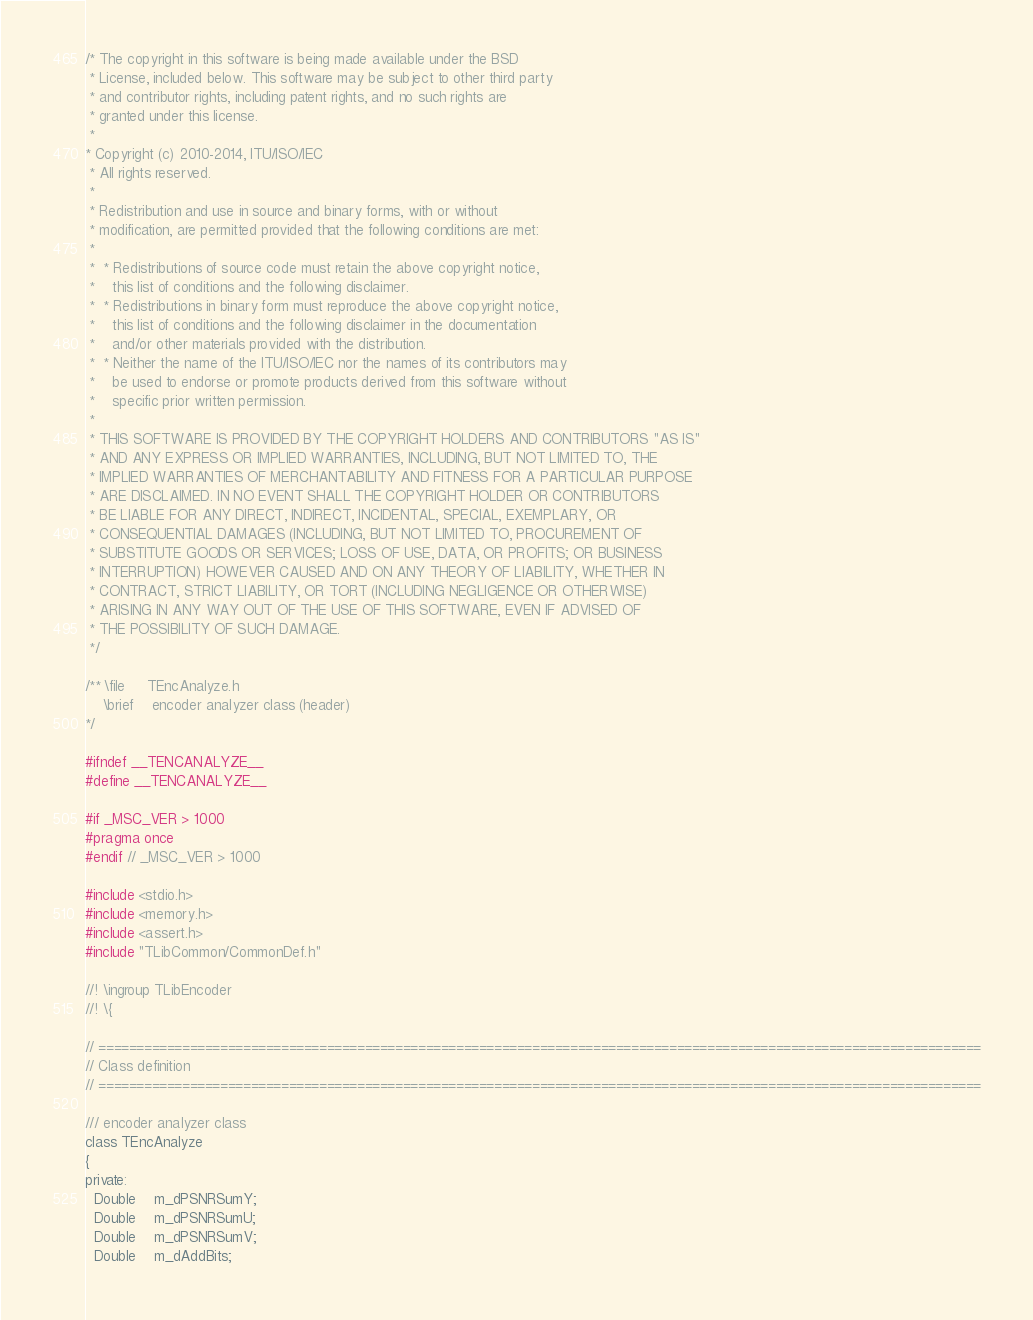<code> <loc_0><loc_0><loc_500><loc_500><_C_>/* The copyright in this software is being made available under the BSD
 * License, included below. This software may be subject to other third party
 * and contributor rights, including patent rights, and no such rights are
 * granted under this license.  
 *
* Copyright (c) 2010-2014, ITU/ISO/IEC
 * All rights reserved.
 *
 * Redistribution and use in source and binary forms, with or without
 * modification, are permitted provided that the following conditions are met:
 *
 *  * Redistributions of source code must retain the above copyright notice,
 *    this list of conditions and the following disclaimer.
 *  * Redistributions in binary form must reproduce the above copyright notice,
 *    this list of conditions and the following disclaimer in the documentation
 *    and/or other materials provided with the distribution.
 *  * Neither the name of the ITU/ISO/IEC nor the names of its contributors may
 *    be used to endorse or promote products derived from this software without
 *    specific prior written permission.
 *
 * THIS SOFTWARE IS PROVIDED BY THE COPYRIGHT HOLDERS AND CONTRIBUTORS "AS IS"
 * AND ANY EXPRESS OR IMPLIED WARRANTIES, INCLUDING, BUT NOT LIMITED TO, THE
 * IMPLIED WARRANTIES OF MERCHANTABILITY AND FITNESS FOR A PARTICULAR PURPOSE
 * ARE DISCLAIMED. IN NO EVENT SHALL THE COPYRIGHT HOLDER OR CONTRIBUTORS
 * BE LIABLE FOR ANY DIRECT, INDIRECT, INCIDENTAL, SPECIAL, EXEMPLARY, OR
 * CONSEQUENTIAL DAMAGES (INCLUDING, BUT NOT LIMITED TO, PROCUREMENT OF
 * SUBSTITUTE GOODS OR SERVICES; LOSS OF USE, DATA, OR PROFITS; OR BUSINESS
 * INTERRUPTION) HOWEVER CAUSED AND ON ANY THEORY OF LIABILITY, WHETHER IN
 * CONTRACT, STRICT LIABILITY, OR TORT (INCLUDING NEGLIGENCE OR OTHERWISE)
 * ARISING IN ANY WAY OUT OF THE USE OF THIS SOFTWARE, EVEN IF ADVISED OF
 * THE POSSIBILITY OF SUCH DAMAGE.
 */

/** \file     TEncAnalyze.h
    \brief    encoder analyzer class (header)
*/

#ifndef __TENCANALYZE__
#define __TENCANALYZE__

#if _MSC_VER > 1000
#pragma once
#endif // _MSC_VER > 1000

#include <stdio.h>
#include <memory.h>
#include <assert.h>
#include "TLibCommon/CommonDef.h"

//! \ingroup TLibEncoder
//! \{

// ====================================================================================================================
// Class definition
// ====================================================================================================================

/// encoder analyzer class
class TEncAnalyze
{
private:
  Double    m_dPSNRSumY;
  Double    m_dPSNRSumU;
  Double    m_dPSNRSumV;
  Double    m_dAddBits;</code> 